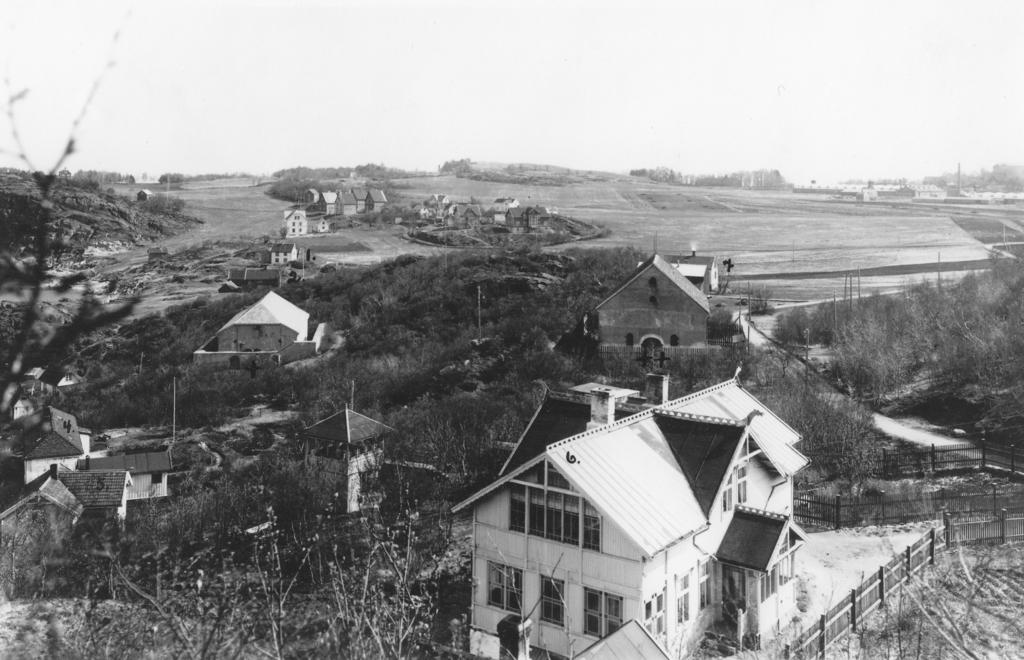What is the color scheme of the image? The image is black and white. What type of structures can be seen in the image? There are buildings in the image. What type of vegetation is present in the image? There are trees and plants in the image. What type of terrain is visible in the image? There is sand in the image. What type of barrier is present in the image? There is fencing in the image. What type of pathway is visible in the image? There is a road in the image. What type of ground cover is present in the image? There is grass in the image. What part of the natural environment is visible in the image? The sky is visible in the image. What type of jeans is the stranger wearing in the image? There is no stranger present in the image, so it is not possible to determine what type of jeans they might be wearing. 